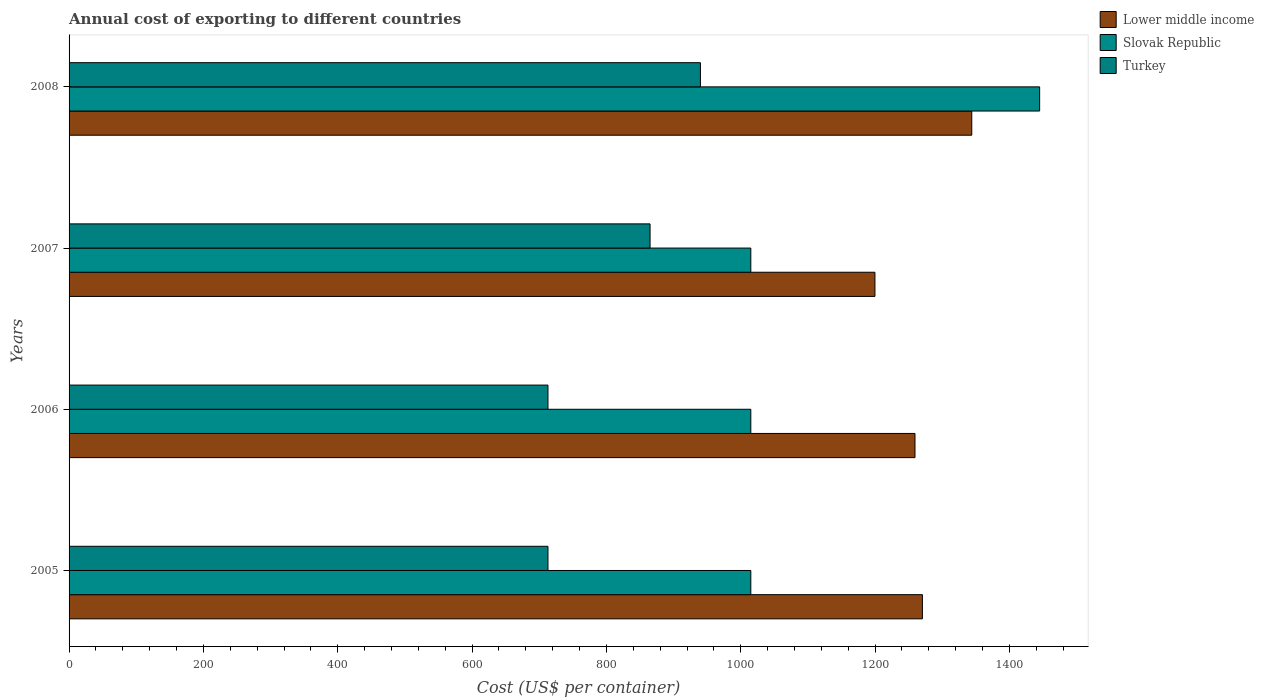How many different coloured bars are there?
Keep it short and to the point. 3. Are the number of bars per tick equal to the number of legend labels?
Provide a short and direct response. Yes. Are the number of bars on each tick of the Y-axis equal?
Offer a very short reply. Yes. What is the total annual cost of exporting in Lower middle income in 2005?
Provide a short and direct response. 1270.47. Across all years, what is the maximum total annual cost of exporting in Turkey?
Provide a short and direct response. 940. Across all years, what is the minimum total annual cost of exporting in Lower middle income?
Provide a succinct answer. 1199.8. In which year was the total annual cost of exporting in Lower middle income maximum?
Your answer should be compact. 2008. What is the total total annual cost of exporting in Turkey in the graph?
Provide a succinct answer. 3231. What is the difference between the total annual cost of exporting in Turkey in 2006 and that in 2007?
Give a very brief answer. -152. What is the difference between the total annual cost of exporting in Turkey in 2006 and the total annual cost of exporting in Slovak Republic in 2007?
Give a very brief answer. -302. What is the average total annual cost of exporting in Slovak Republic per year?
Your response must be concise. 1122.5. In the year 2008, what is the difference between the total annual cost of exporting in Lower middle income and total annual cost of exporting in Turkey?
Make the answer very short. 403.96. What is the ratio of the total annual cost of exporting in Turkey in 2005 to that in 2008?
Provide a short and direct response. 0.76. Is the difference between the total annual cost of exporting in Lower middle income in 2005 and 2008 greater than the difference between the total annual cost of exporting in Turkey in 2005 and 2008?
Offer a very short reply. Yes. What is the difference between the highest and the second highest total annual cost of exporting in Lower middle income?
Your answer should be very brief. 73.49. What is the difference between the highest and the lowest total annual cost of exporting in Slovak Republic?
Your response must be concise. 430. Is the sum of the total annual cost of exporting in Lower middle income in 2005 and 2008 greater than the maximum total annual cost of exporting in Turkey across all years?
Make the answer very short. Yes. What does the 2nd bar from the bottom in 2007 represents?
Your response must be concise. Slovak Republic. How many bars are there?
Offer a very short reply. 12. Are all the bars in the graph horizontal?
Keep it short and to the point. Yes. How many years are there in the graph?
Your response must be concise. 4. What is the difference between two consecutive major ticks on the X-axis?
Provide a succinct answer. 200. Does the graph contain any zero values?
Your answer should be compact. No. How are the legend labels stacked?
Offer a terse response. Vertical. What is the title of the graph?
Keep it short and to the point. Annual cost of exporting to different countries. Does "Thailand" appear as one of the legend labels in the graph?
Provide a short and direct response. No. What is the label or title of the X-axis?
Give a very brief answer. Cost (US$ per container). What is the Cost (US$ per container) in Lower middle income in 2005?
Offer a terse response. 1270.47. What is the Cost (US$ per container) in Slovak Republic in 2005?
Provide a succinct answer. 1015. What is the Cost (US$ per container) of Turkey in 2005?
Your answer should be compact. 713. What is the Cost (US$ per container) in Lower middle income in 2006?
Make the answer very short. 1259.41. What is the Cost (US$ per container) in Slovak Republic in 2006?
Provide a succinct answer. 1015. What is the Cost (US$ per container) in Turkey in 2006?
Provide a succinct answer. 713. What is the Cost (US$ per container) of Lower middle income in 2007?
Your response must be concise. 1199.8. What is the Cost (US$ per container) of Slovak Republic in 2007?
Provide a short and direct response. 1015. What is the Cost (US$ per container) of Turkey in 2007?
Keep it short and to the point. 865. What is the Cost (US$ per container) in Lower middle income in 2008?
Provide a succinct answer. 1343.96. What is the Cost (US$ per container) in Slovak Republic in 2008?
Give a very brief answer. 1445. What is the Cost (US$ per container) of Turkey in 2008?
Make the answer very short. 940. Across all years, what is the maximum Cost (US$ per container) in Lower middle income?
Provide a succinct answer. 1343.96. Across all years, what is the maximum Cost (US$ per container) of Slovak Republic?
Ensure brevity in your answer.  1445. Across all years, what is the maximum Cost (US$ per container) of Turkey?
Provide a succinct answer. 940. Across all years, what is the minimum Cost (US$ per container) of Lower middle income?
Keep it short and to the point. 1199.8. Across all years, what is the minimum Cost (US$ per container) of Slovak Republic?
Offer a terse response. 1015. Across all years, what is the minimum Cost (US$ per container) of Turkey?
Make the answer very short. 713. What is the total Cost (US$ per container) of Lower middle income in the graph?
Provide a short and direct response. 5073.63. What is the total Cost (US$ per container) of Slovak Republic in the graph?
Give a very brief answer. 4490. What is the total Cost (US$ per container) of Turkey in the graph?
Offer a very short reply. 3231. What is the difference between the Cost (US$ per container) in Lower middle income in 2005 and that in 2006?
Make the answer very short. 11.06. What is the difference between the Cost (US$ per container) in Turkey in 2005 and that in 2006?
Offer a terse response. 0. What is the difference between the Cost (US$ per container) in Lower middle income in 2005 and that in 2007?
Ensure brevity in your answer.  70.67. What is the difference between the Cost (US$ per container) in Slovak Republic in 2005 and that in 2007?
Offer a very short reply. 0. What is the difference between the Cost (US$ per container) of Turkey in 2005 and that in 2007?
Ensure brevity in your answer.  -152. What is the difference between the Cost (US$ per container) of Lower middle income in 2005 and that in 2008?
Offer a terse response. -73.49. What is the difference between the Cost (US$ per container) of Slovak Republic in 2005 and that in 2008?
Offer a very short reply. -430. What is the difference between the Cost (US$ per container) of Turkey in 2005 and that in 2008?
Ensure brevity in your answer.  -227. What is the difference between the Cost (US$ per container) of Lower middle income in 2006 and that in 2007?
Your answer should be very brief. 59.61. What is the difference between the Cost (US$ per container) in Slovak Republic in 2006 and that in 2007?
Provide a short and direct response. 0. What is the difference between the Cost (US$ per container) of Turkey in 2006 and that in 2007?
Your response must be concise. -152. What is the difference between the Cost (US$ per container) of Lower middle income in 2006 and that in 2008?
Give a very brief answer. -84.55. What is the difference between the Cost (US$ per container) of Slovak Republic in 2006 and that in 2008?
Your response must be concise. -430. What is the difference between the Cost (US$ per container) of Turkey in 2006 and that in 2008?
Make the answer very short. -227. What is the difference between the Cost (US$ per container) in Lower middle income in 2007 and that in 2008?
Your answer should be compact. -144.16. What is the difference between the Cost (US$ per container) of Slovak Republic in 2007 and that in 2008?
Your answer should be compact. -430. What is the difference between the Cost (US$ per container) of Turkey in 2007 and that in 2008?
Offer a terse response. -75. What is the difference between the Cost (US$ per container) in Lower middle income in 2005 and the Cost (US$ per container) in Slovak Republic in 2006?
Ensure brevity in your answer.  255.47. What is the difference between the Cost (US$ per container) in Lower middle income in 2005 and the Cost (US$ per container) in Turkey in 2006?
Provide a succinct answer. 557.47. What is the difference between the Cost (US$ per container) in Slovak Republic in 2005 and the Cost (US$ per container) in Turkey in 2006?
Provide a succinct answer. 302. What is the difference between the Cost (US$ per container) of Lower middle income in 2005 and the Cost (US$ per container) of Slovak Republic in 2007?
Offer a terse response. 255.47. What is the difference between the Cost (US$ per container) in Lower middle income in 2005 and the Cost (US$ per container) in Turkey in 2007?
Make the answer very short. 405.47. What is the difference between the Cost (US$ per container) of Slovak Republic in 2005 and the Cost (US$ per container) of Turkey in 2007?
Offer a terse response. 150. What is the difference between the Cost (US$ per container) in Lower middle income in 2005 and the Cost (US$ per container) in Slovak Republic in 2008?
Ensure brevity in your answer.  -174.53. What is the difference between the Cost (US$ per container) of Lower middle income in 2005 and the Cost (US$ per container) of Turkey in 2008?
Your answer should be compact. 330.47. What is the difference between the Cost (US$ per container) in Slovak Republic in 2005 and the Cost (US$ per container) in Turkey in 2008?
Offer a very short reply. 75. What is the difference between the Cost (US$ per container) in Lower middle income in 2006 and the Cost (US$ per container) in Slovak Republic in 2007?
Your answer should be compact. 244.41. What is the difference between the Cost (US$ per container) in Lower middle income in 2006 and the Cost (US$ per container) in Turkey in 2007?
Ensure brevity in your answer.  394.41. What is the difference between the Cost (US$ per container) of Slovak Republic in 2006 and the Cost (US$ per container) of Turkey in 2007?
Provide a short and direct response. 150. What is the difference between the Cost (US$ per container) in Lower middle income in 2006 and the Cost (US$ per container) in Slovak Republic in 2008?
Keep it short and to the point. -185.59. What is the difference between the Cost (US$ per container) of Lower middle income in 2006 and the Cost (US$ per container) of Turkey in 2008?
Your answer should be compact. 319.41. What is the difference between the Cost (US$ per container) of Slovak Republic in 2006 and the Cost (US$ per container) of Turkey in 2008?
Ensure brevity in your answer.  75. What is the difference between the Cost (US$ per container) of Lower middle income in 2007 and the Cost (US$ per container) of Slovak Republic in 2008?
Ensure brevity in your answer.  -245.2. What is the difference between the Cost (US$ per container) of Lower middle income in 2007 and the Cost (US$ per container) of Turkey in 2008?
Ensure brevity in your answer.  259.8. What is the difference between the Cost (US$ per container) in Slovak Republic in 2007 and the Cost (US$ per container) in Turkey in 2008?
Provide a succinct answer. 75. What is the average Cost (US$ per container) in Lower middle income per year?
Give a very brief answer. 1268.41. What is the average Cost (US$ per container) of Slovak Republic per year?
Ensure brevity in your answer.  1122.5. What is the average Cost (US$ per container) of Turkey per year?
Provide a succinct answer. 807.75. In the year 2005, what is the difference between the Cost (US$ per container) of Lower middle income and Cost (US$ per container) of Slovak Republic?
Provide a succinct answer. 255.47. In the year 2005, what is the difference between the Cost (US$ per container) in Lower middle income and Cost (US$ per container) in Turkey?
Your response must be concise. 557.47. In the year 2005, what is the difference between the Cost (US$ per container) in Slovak Republic and Cost (US$ per container) in Turkey?
Your response must be concise. 302. In the year 2006, what is the difference between the Cost (US$ per container) in Lower middle income and Cost (US$ per container) in Slovak Republic?
Make the answer very short. 244.41. In the year 2006, what is the difference between the Cost (US$ per container) in Lower middle income and Cost (US$ per container) in Turkey?
Provide a succinct answer. 546.41. In the year 2006, what is the difference between the Cost (US$ per container) of Slovak Republic and Cost (US$ per container) of Turkey?
Your answer should be compact. 302. In the year 2007, what is the difference between the Cost (US$ per container) of Lower middle income and Cost (US$ per container) of Slovak Republic?
Make the answer very short. 184.8. In the year 2007, what is the difference between the Cost (US$ per container) in Lower middle income and Cost (US$ per container) in Turkey?
Provide a short and direct response. 334.8. In the year 2007, what is the difference between the Cost (US$ per container) in Slovak Republic and Cost (US$ per container) in Turkey?
Offer a very short reply. 150. In the year 2008, what is the difference between the Cost (US$ per container) of Lower middle income and Cost (US$ per container) of Slovak Republic?
Offer a terse response. -101.04. In the year 2008, what is the difference between the Cost (US$ per container) in Lower middle income and Cost (US$ per container) in Turkey?
Keep it short and to the point. 403.96. In the year 2008, what is the difference between the Cost (US$ per container) of Slovak Republic and Cost (US$ per container) of Turkey?
Provide a short and direct response. 505. What is the ratio of the Cost (US$ per container) in Lower middle income in 2005 to that in 2006?
Your answer should be very brief. 1.01. What is the ratio of the Cost (US$ per container) in Slovak Republic in 2005 to that in 2006?
Your answer should be compact. 1. What is the ratio of the Cost (US$ per container) in Turkey in 2005 to that in 2006?
Offer a terse response. 1. What is the ratio of the Cost (US$ per container) in Lower middle income in 2005 to that in 2007?
Make the answer very short. 1.06. What is the ratio of the Cost (US$ per container) of Turkey in 2005 to that in 2007?
Offer a very short reply. 0.82. What is the ratio of the Cost (US$ per container) of Lower middle income in 2005 to that in 2008?
Your answer should be very brief. 0.95. What is the ratio of the Cost (US$ per container) of Slovak Republic in 2005 to that in 2008?
Offer a terse response. 0.7. What is the ratio of the Cost (US$ per container) in Turkey in 2005 to that in 2008?
Provide a short and direct response. 0.76. What is the ratio of the Cost (US$ per container) of Lower middle income in 2006 to that in 2007?
Ensure brevity in your answer.  1.05. What is the ratio of the Cost (US$ per container) of Slovak Republic in 2006 to that in 2007?
Keep it short and to the point. 1. What is the ratio of the Cost (US$ per container) in Turkey in 2006 to that in 2007?
Provide a succinct answer. 0.82. What is the ratio of the Cost (US$ per container) in Lower middle income in 2006 to that in 2008?
Provide a short and direct response. 0.94. What is the ratio of the Cost (US$ per container) in Slovak Republic in 2006 to that in 2008?
Offer a terse response. 0.7. What is the ratio of the Cost (US$ per container) in Turkey in 2006 to that in 2008?
Keep it short and to the point. 0.76. What is the ratio of the Cost (US$ per container) of Lower middle income in 2007 to that in 2008?
Offer a very short reply. 0.89. What is the ratio of the Cost (US$ per container) of Slovak Republic in 2007 to that in 2008?
Offer a very short reply. 0.7. What is the ratio of the Cost (US$ per container) of Turkey in 2007 to that in 2008?
Give a very brief answer. 0.92. What is the difference between the highest and the second highest Cost (US$ per container) of Lower middle income?
Your response must be concise. 73.49. What is the difference between the highest and the second highest Cost (US$ per container) in Slovak Republic?
Provide a short and direct response. 430. What is the difference between the highest and the second highest Cost (US$ per container) in Turkey?
Provide a short and direct response. 75. What is the difference between the highest and the lowest Cost (US$ per container) in Lower middle income?
Provide a short and direct response. 144.16. What is the difference between the highest and the lowest Cost (US$ per container) in Slovak Republic?
Your answer should be compact. 430. What is the difference between the highest and the lowest Cost (US$ per container) in Turkey?
Offer a very short reply. 227. 